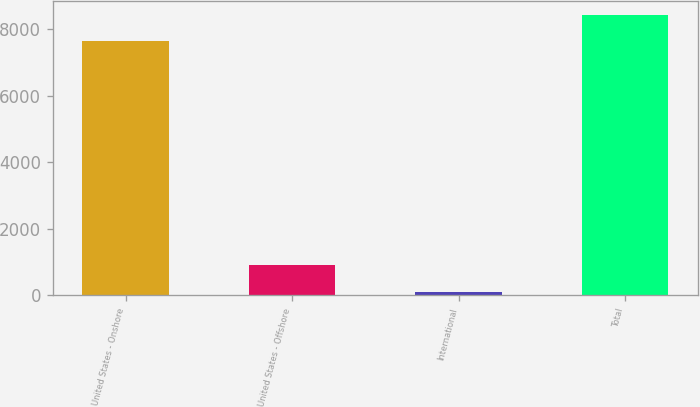Convert chart. <chart><loc_0><loc_0><loc_500><loc_500><bar_chart><fcel>United States - Onshore<fcel>United States - Offshore<fcel>International<fcel>Total<nl><fcel>7640.8<fcel>899.84<fcel>117<fcel>8423.64<nl></chart> 